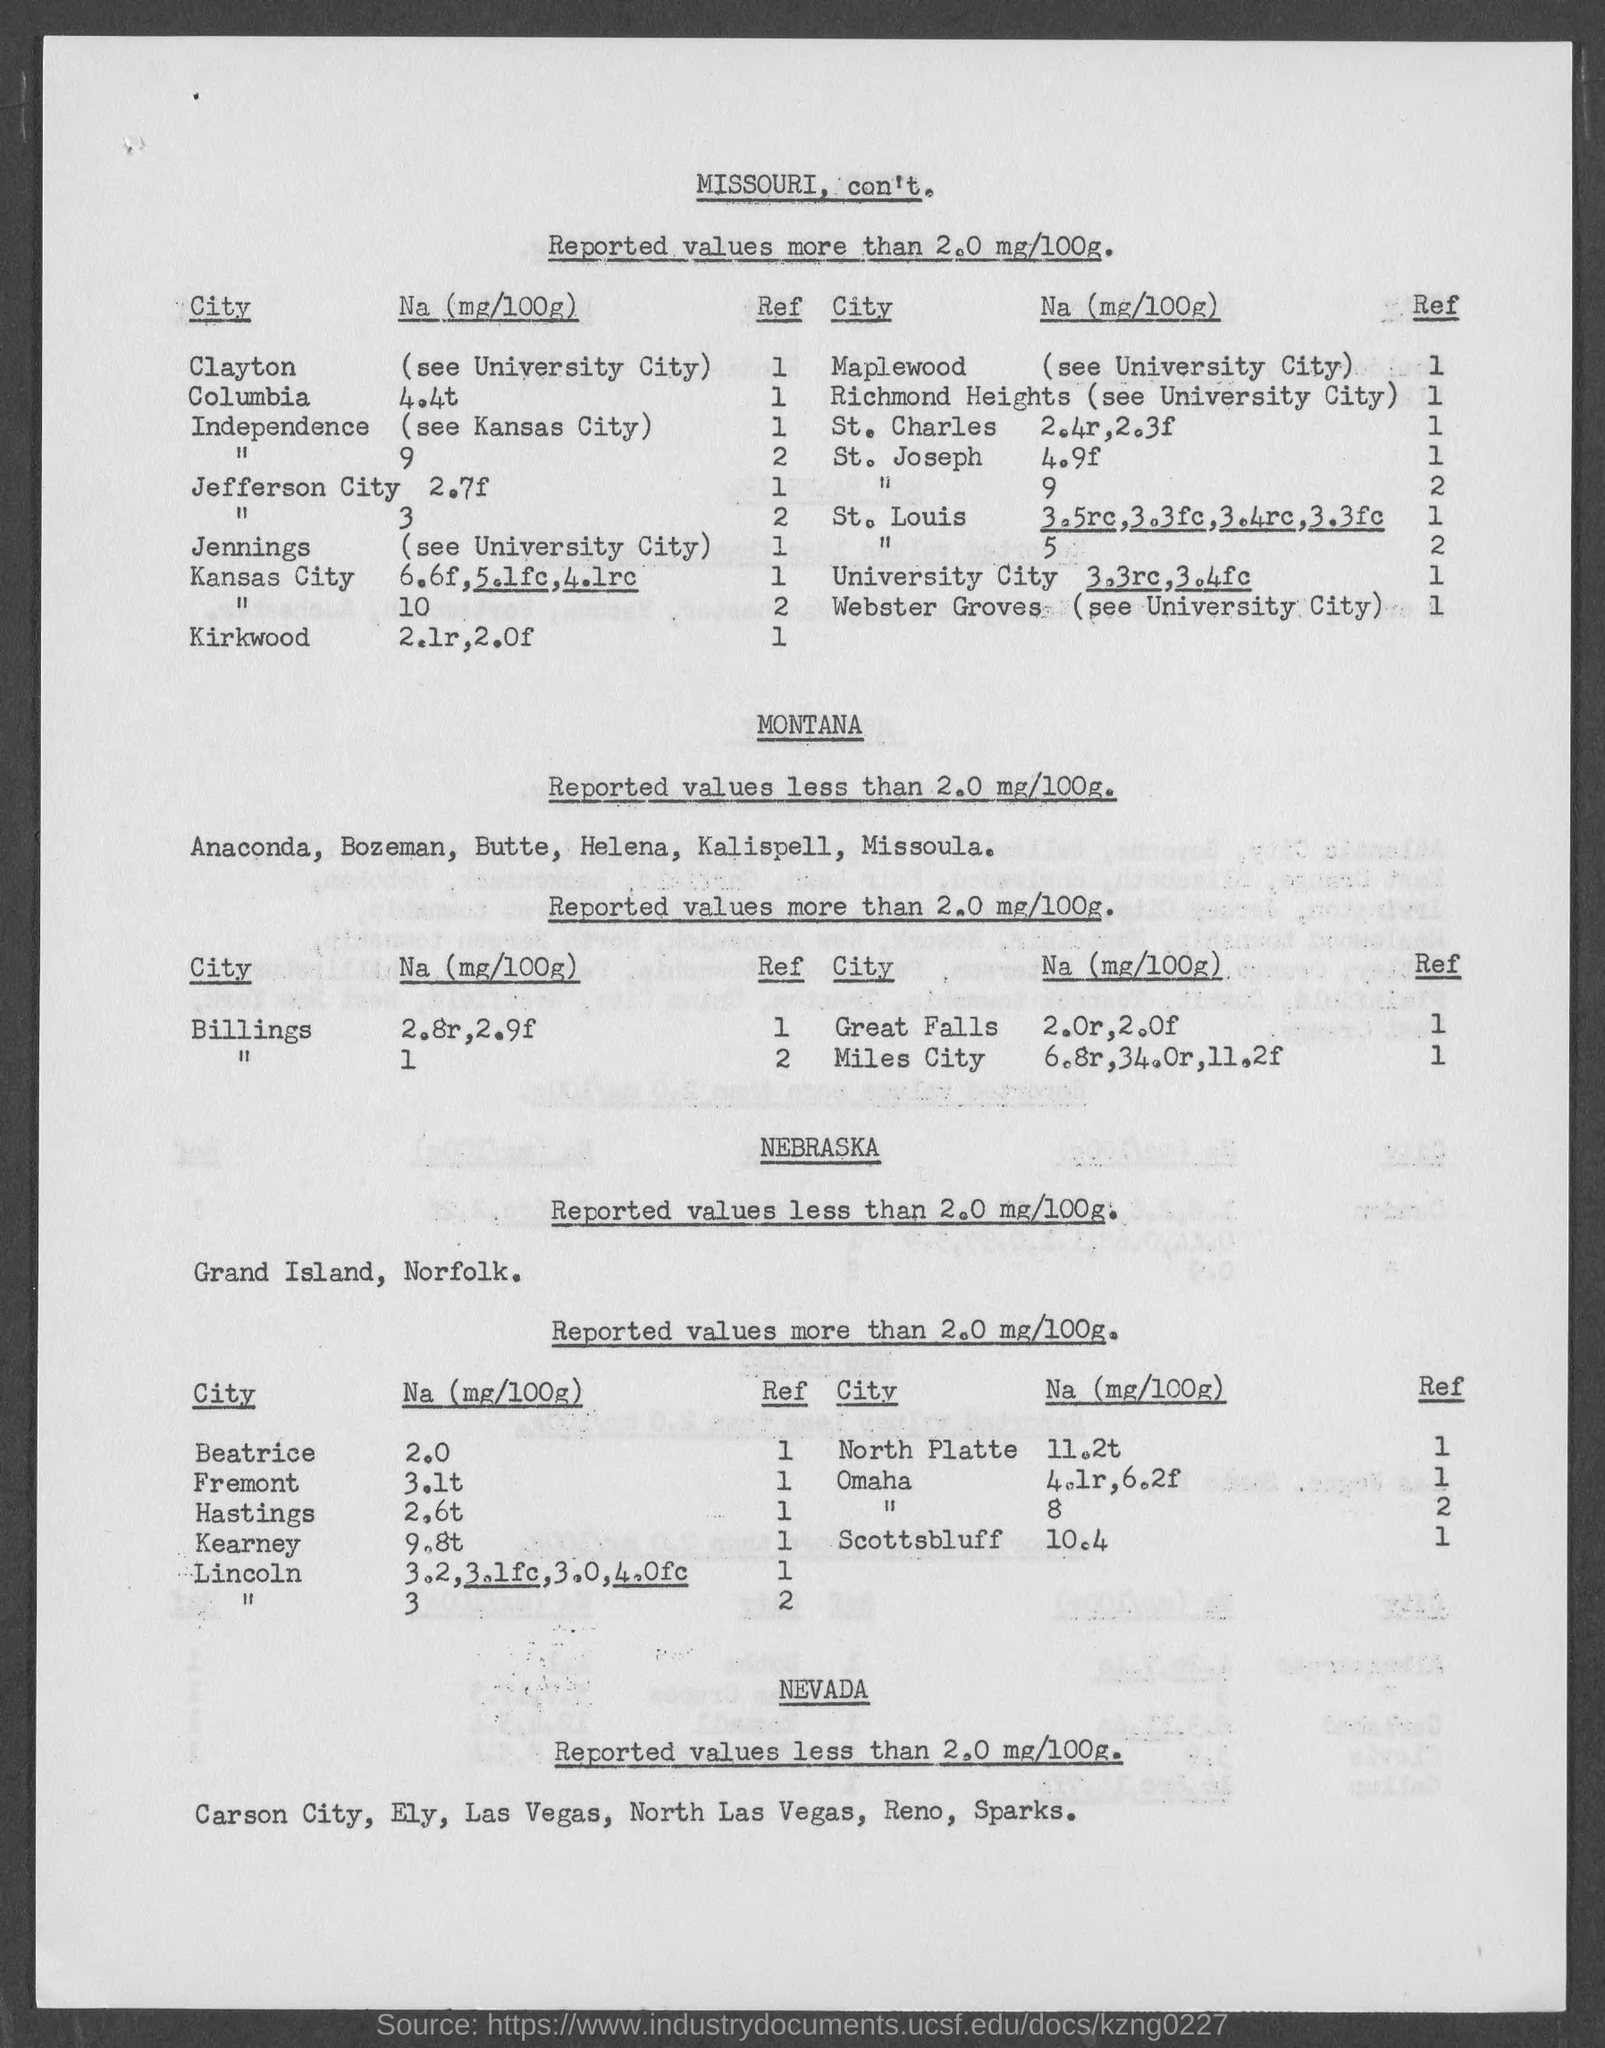Point out several critical features in this image. The Na (mg/100g) for Hastings is 2.6t. The Na (mg/100g) for North Platte is 11.2 tonnes per 100 grams. Beatrice has a Na (mg/100g) of 2.0. The Na (mg/100g) for Scottsbluff is 10.4. The Na (mg/100g) for Kearney is 9.8 tonnes. 